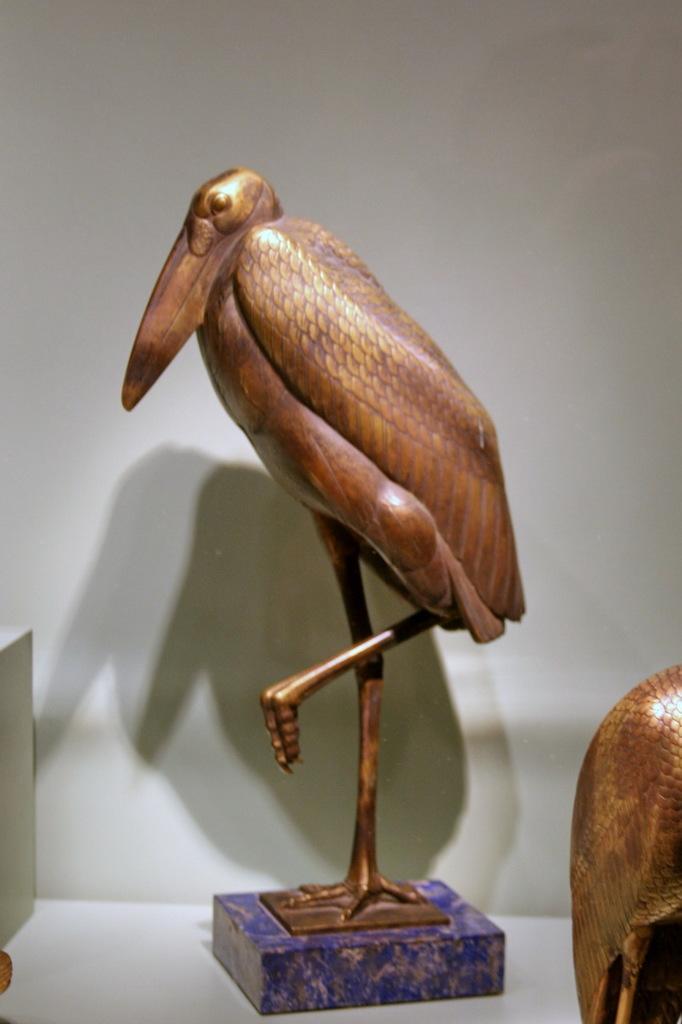Can you describe this image briefly? In this image we can see statues. There is a white background. 